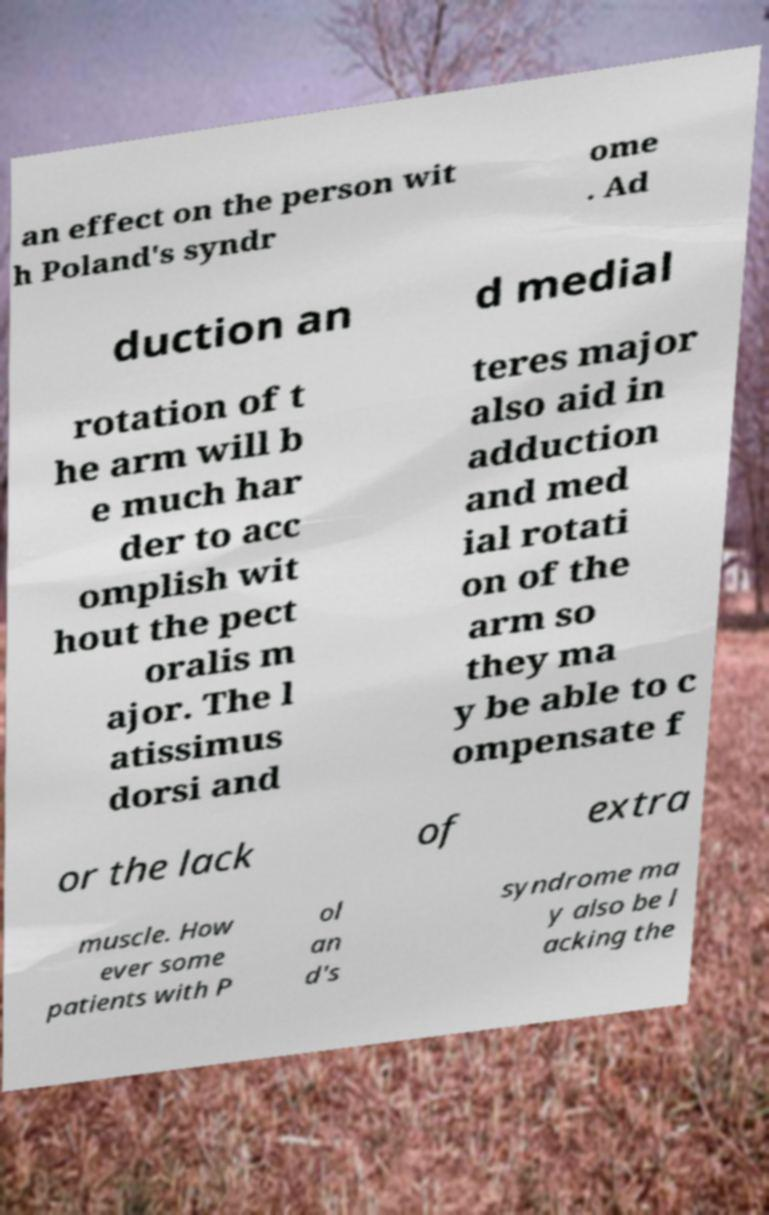I need the written content from this picture converted into text. Can you do that? an effect on the person wit h Poland's syndr ome . Ad duction an d medial rotation of t he arm will b e much har der to acc omplish wit hout the pect oralis m ajor. The l atissimus dorsi and teres major also aid in adduction and med ial rotati on of the arm so they ma y be able to c ompensate f or the lack of extra muscle. How ever some patients with P ol an d's syndrome ma y also be l acking the 